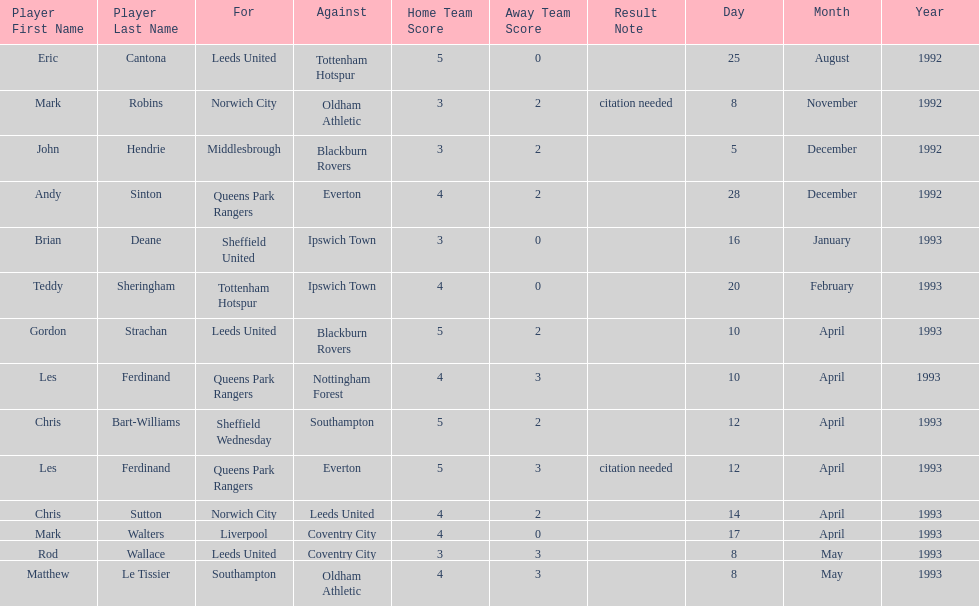Name the only player from france. Eric Cantona. 